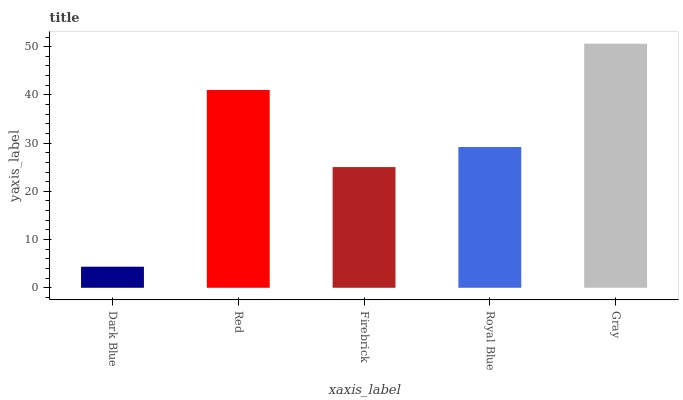Is Dark Blue the minimum?
Answer yes or no. Yes. Is Gray the maximum?
Answer yes or no. Yes. Is Red the minimum?
Answer yes or no. No. Is Red the maximum?
Answer yes or no. No. Is Red greater than Dark Blue?
Answer yes or no. Yes. Is Dark Blue less than Red?
Answer yes or no. Yes. Is Dark Blue greater than Red?
Answer yes or no. No. Is Red less than Dark Blue?
Answer yes or no. No. Is Royal Blue the high median?
Answer yes or no. Yes. Is Royal Blue the low median?
Answer yes or no. Yes. Is Firebrick the high median?
Answer yes or no. No. Is Gray the low median?
Answer yes or no. No. 